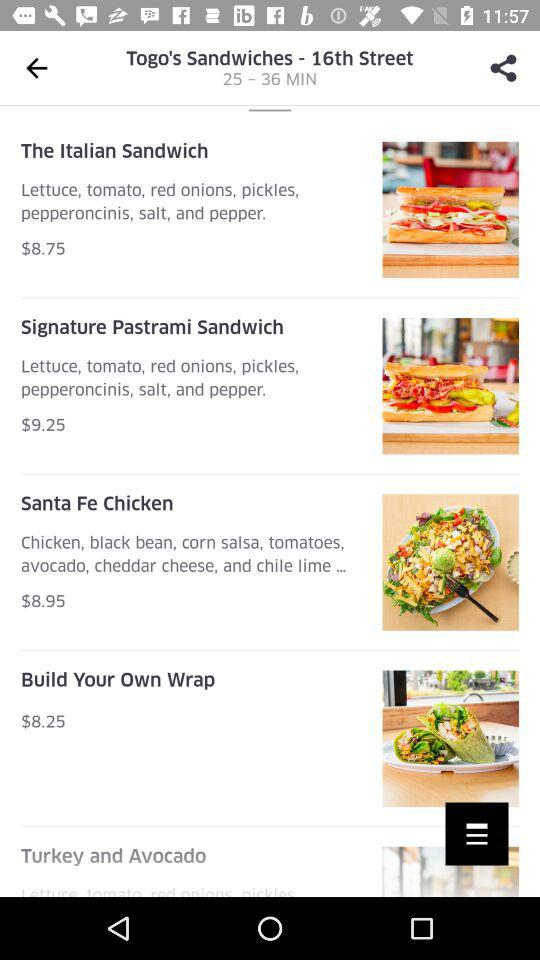How much more expensive is the Signature Pastrami Sandwich than the Santa Fe Chicken?
Answer the question using a single word or phrase. $0.30 